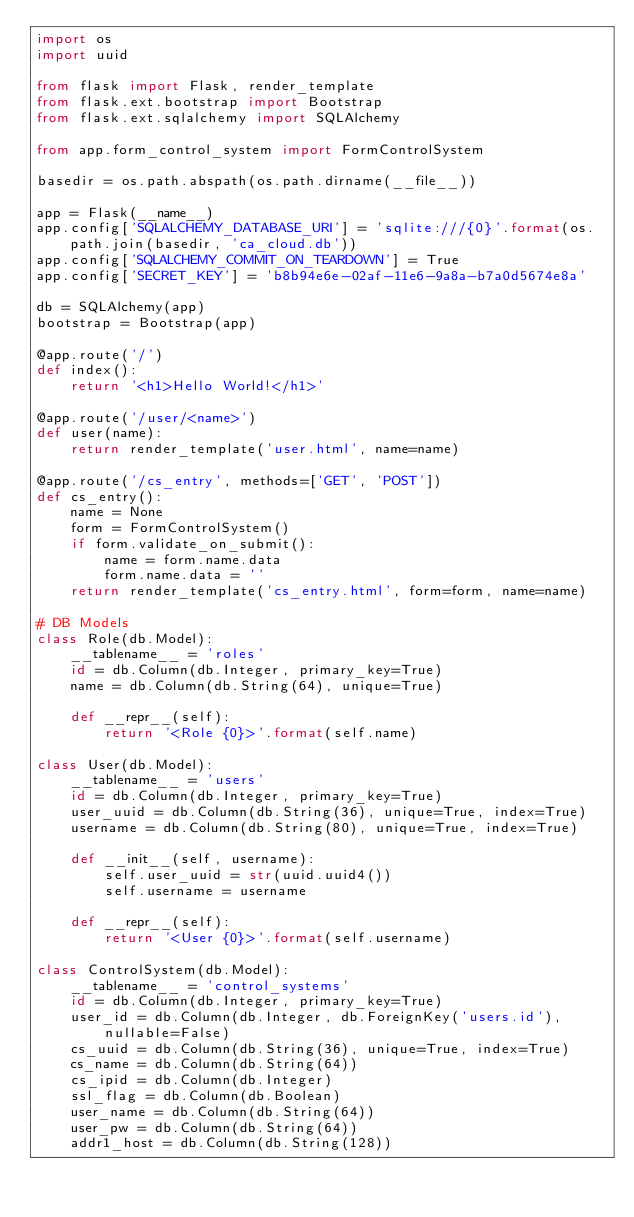<code> <loc_0><loc_0><loc_500><loc_500><_Python_>import os
import uuid

from flask import Flask, render_template
from flask.ext.bootstrap import Bootstrap
from flask.ext.sqlalchemy import SQLAlchemy

from app.form_control_system import FormControlSystem

basedir = os.path.abspath(os.path.dirname(__file__))

app = Flask(__name__)
app.config['SQLALCHEMY_DATABASE_URI'] = 'sqlite:///{0}'.format(os.path.join(basedir, 'ca_cloud.db'))
app.config['SQLALCHEMY_COMMIT_ON_TEARDOWN'] = True
app.config['SECRET_KEY'] = 'b8b94e6e-02af-11e6-9a8a-b7a0d5674e8a'

db = SQLAlchemy(app)
bootstrap = Bootstrap(app)

@app.route('/')
def index():
    return '<h1>Hello World!</h1>'

@app.route('/user/<name>')
def user(name):
    return render_template('user.html', name=name)

@app.route('/cs_entry', methods=['GET', 'POST'])
def cs_entry():
    name = None
    form = FormControlSystem()
    if form.validate_on_submit():
        name = form.name.data
        form.name.data = ''
    return render_template('cs_entry.html', form=form, name=name)

# DB Models
class Role(db.Model):
    __tablename__ = 'roles'
    id = db.Column(db.Integer, primary_key=True)
    name = db.Column(db.String(64), unique=True)

    def __repr__(self):
        return '<Role {0}>'.format(self.name)

class User(db.Model):
    __tablename__ = 'users'
    id = db.Column(db.Integer, primary_key=True)
    user_uuid = db.Column(db.String(36), unique=True, index=True)
    username = db.Column(db.String(80), unique=True, index=True)

    def __init__(self, username):
        self.user_uuid = str(uuid.uuid4())
        self.username = username

    def __repr__(self):
        return '<User {0}>'.format(self.username)

class ControlSystem(db.Model):
    __tablename__ = 'control_systems'
    id = db.Column(db.Integer, primary_key=True)
    user_id = db.Column(db.Integer, db.ForeignKey('users.id'), nullable=False)
    cs_uuid = db.Column(db.String(36), unique=True, index=True)
    cs_name = db.Column(db.String(64))
    cs_ipid = db.Column(db.Integer)
    ssl_flag = db.Column(db.Boolean)
    user_name = db.Column(db.String(64))
    user_pw = db.Column(db.String(64))
    addr1_host = db.Column(db.String(128))</code> 